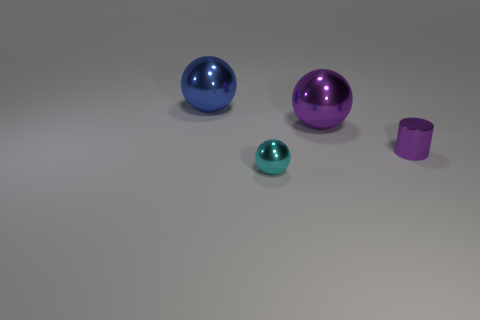Add 3 tiny cyan matte cylinders. How many objects exist? 7 Subtract all balls. How many objects are left? 1 Subtract 0 brown blocks. How many objects are left? 4 Subtract all tiny metal spheres. Subtract all tiny gray metallic cylinders. How many objects are left? 3 Add 3 balls. How many balls are left? 6 Add 4 big green shiny objects. How many big green shiny objects exist? 4 